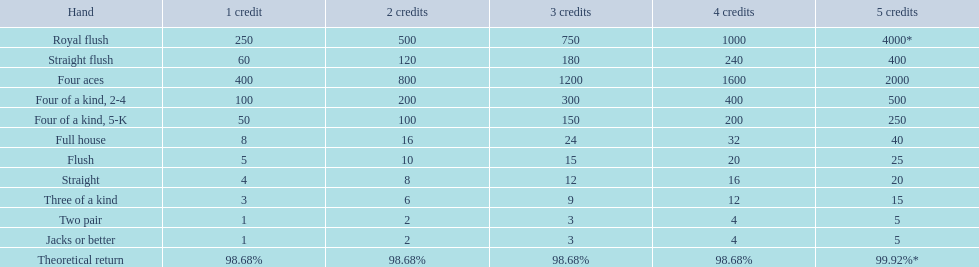Which possesses a higher status: a straight or a flush? Flush. 